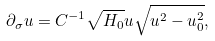<formula> <loc_0><loc_0><loc_500><loc_500>\partial _ { \sigma } u = C ^ { - 1 } \sqrt { H _ { 0 } } u \sqrt { u ^ { 2 } - u _ { 0 } ^ { 2 } } ,</formula> 